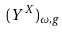<formula> <loc_0><loc_0><loc_500><loc_500>( Y ^ { X } ) _ { \omega , g }</formula> 